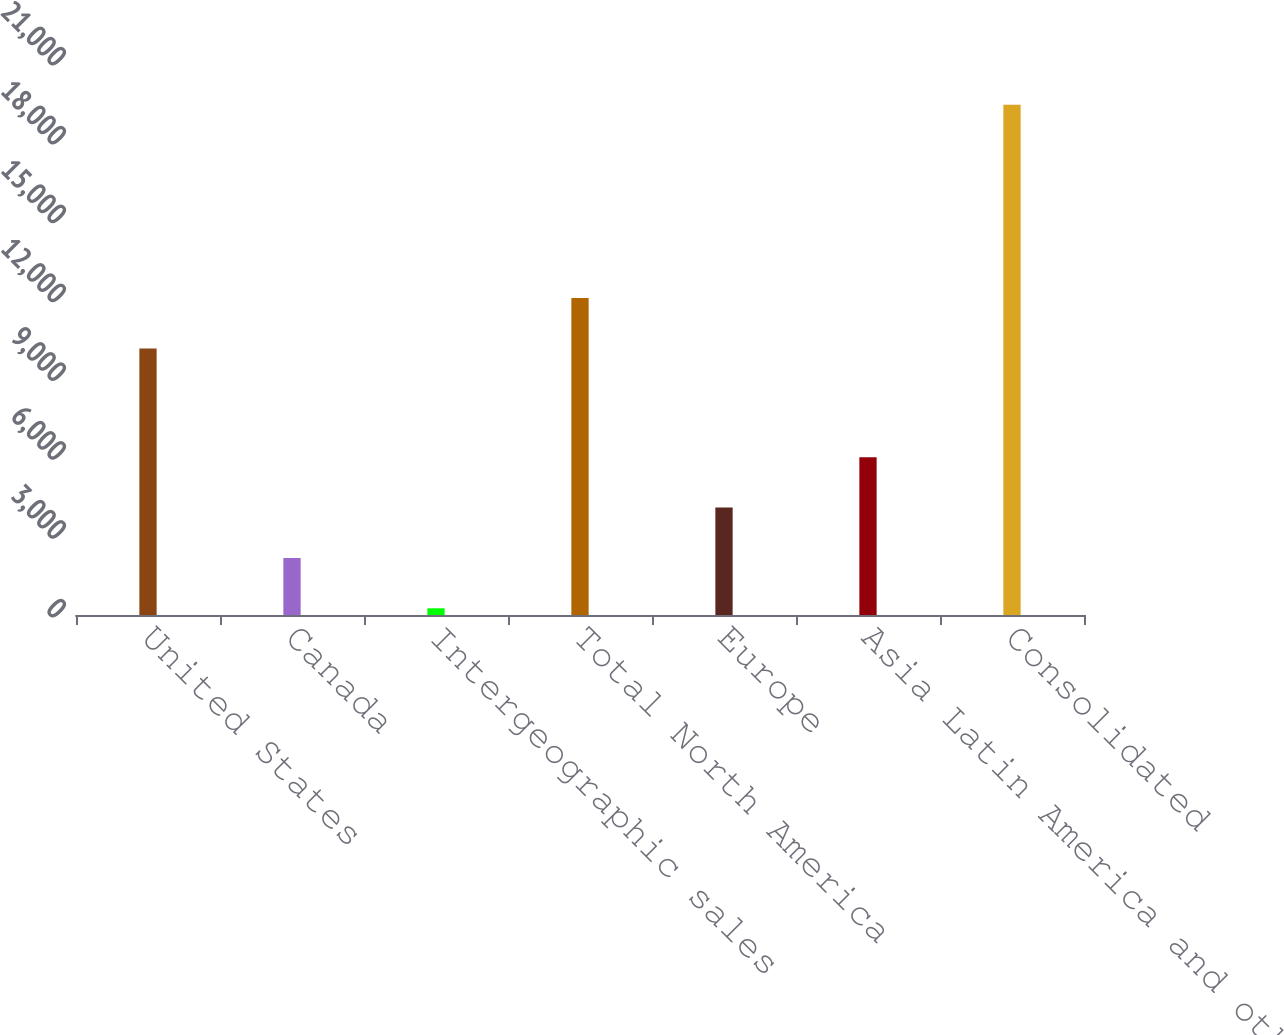Convert chart. <chart><loc_0><loc_0><loc_500><loc_500><bar_chart><fcel>United States<fcel>Canada<fcel>Intergeographic sales<fcel>Total North America<fcel>Europe<fcel>Asia Latin America and other<fcel>Consolidated<nl><fcel>10143<fcel>2171.9<fcel>256<fcel>12058.9<fcel>4087.8<fcel>6003.7<fcel>19415<nl></chart> 